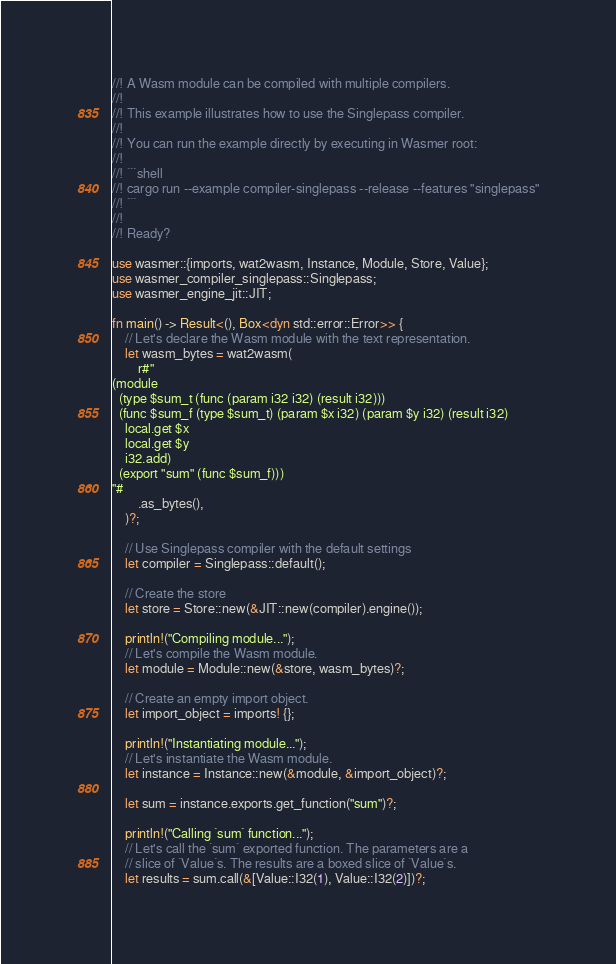<code> <loc_0><loc_0><loc_500><loc_500><_Rust_>//! A Wasm module can be compiled with multiple compilers.
//!
//! This example illustrates how to use the Singlepass compiler.
//!
//! You can run the example directly by executing in Wasmer root:
//!
//! ```shell
//! cargo run --example compiler-singlepass --release --features "singlepass"
//! ```
//!
//! Ready?

use wasmer::{imports, wat2wasm, Instance, Module, Store, Value};
use wasmer_compiler_singlepass::Singlepass;
use wasmer_engine_jit::JIT;

fn main() -> Result<(), Box<dyn std::error::Error>> {
    // Let's declare the Wasm module with the text representation.
    let wasm_bytes = wat2wasm(
        r#"
(module
  (type $sum_t (func (param i32 i32) (result i32)))
  (func $sum_f (type $sum_t) (param $x i32) (param $y i32) (result i32)
    local.get $x
    local.get $y
    i32.add)
  (export "sum" (func $sum_f)))
"#
        .as_bytes(),
    )?;

    // Use Singlepass compiler with the default settings
    let compiler = Singlepass::default();

    // Create the store
    let store = Store::new(&JIT::new(compiler).engine());

    println!("Compiling module...");
    // Let's compile the Wasm module.
    let module = Module::new(&store, wasm_bytes)?;

    // Create an empty import object.
    let import_object = imports! {};

    println!("Instantiating module...");
    // Let's instantiate the Wasm module.
    let instance = Instance::new(&module, &import_object)?;

    let sum = instance.exports.get_function("sum")?;

    println!("Calling `sum` function...");
    // Let's call the `sum` exported function. The parameters are a
    // slice of `Value`s. The results are a boxed slice of `Value`s.
    let results = sum.call(&[Value::I32(1), Value::I32(2)])?;
</code> 